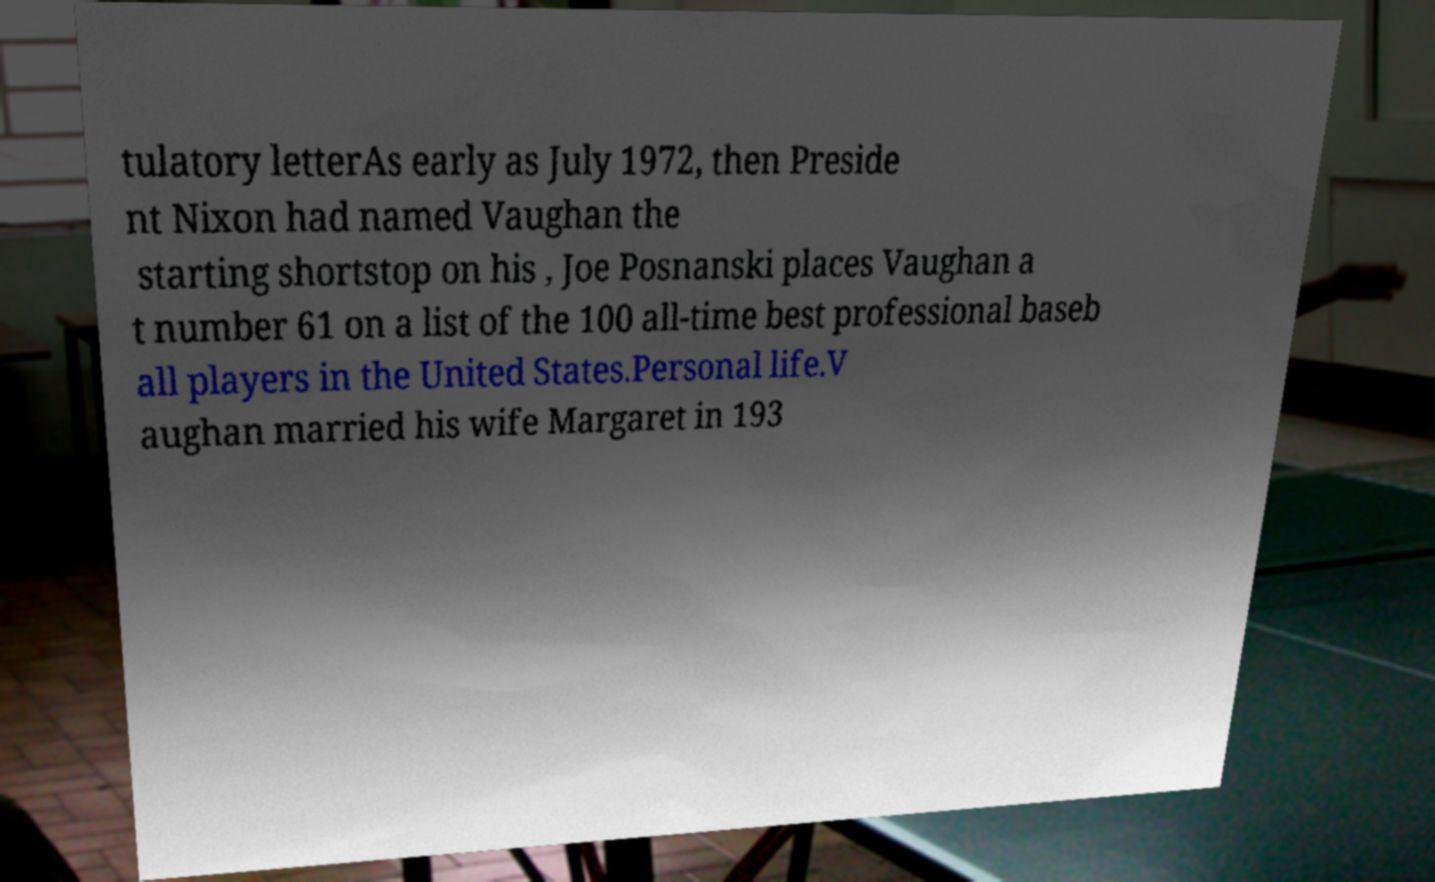I need the written content from this picture converted into text. Can you do that? tulatory letterAs early as July 1972, then Preside nt Nixon had named Vaughan the starting shortstop on his , Joe Posnanski places Vaughan a t number 61 on a list of the 100 all-time best professional baseb all players in the United States.Personal life.V aughan married his wife Margaret in 193 